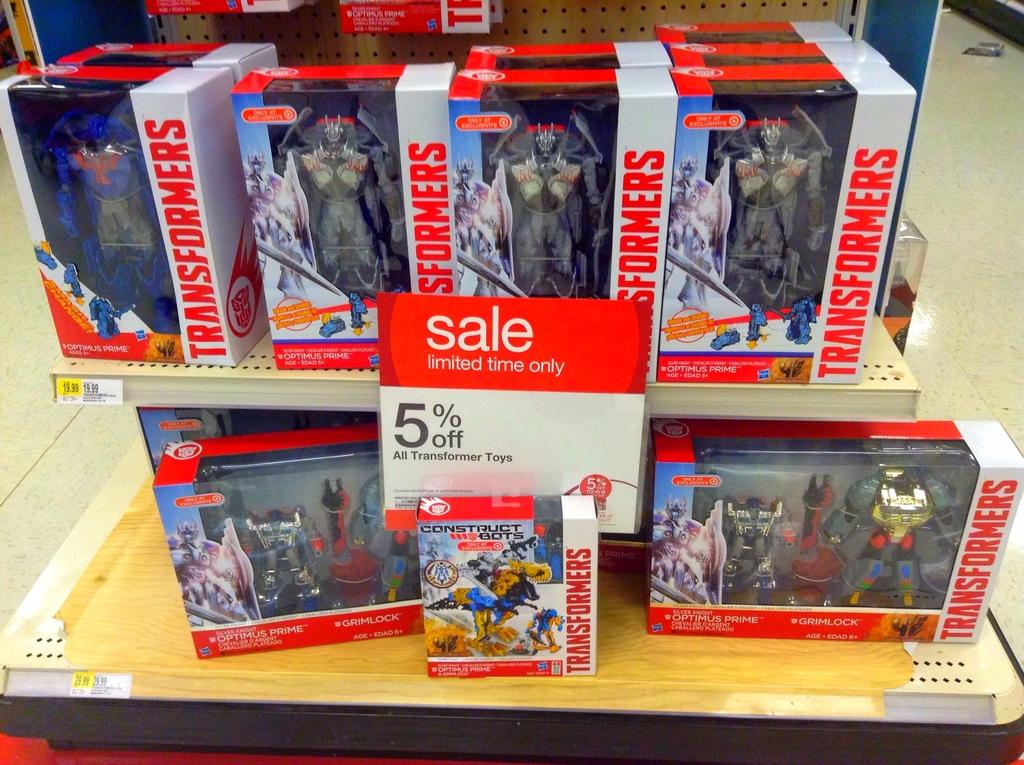What type of stand is visible in the image? There is a wooden stand in the image. What is placed on the wooden stand? There are boxes on the wooden stand. What can be seen on the boxes? There is text on the boxes. What is inside the boxes? There are toys inside the boxes. What type of hose is used for the distribution of liquid in the image? There is no hose or liquid distribution present in the image. 